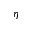<formula> <loc_0><loc_0><loc_500><loc_500>\eta</formula> 